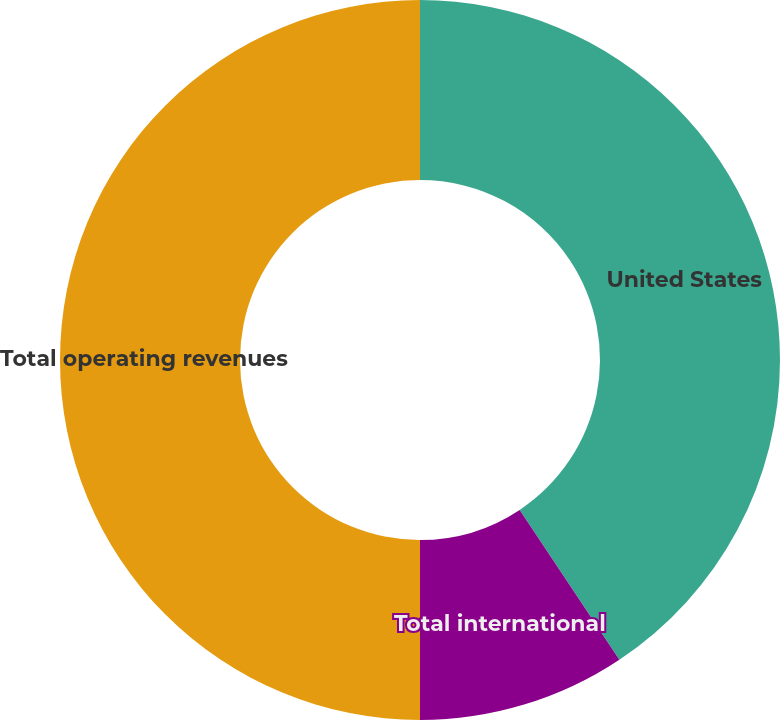Convert chart to OTSL. <chart><loc_0><loc_0><loc_500><loc_500><pie_chart><fcel>United States<fcel>Total international<fcel>Total operating revenues<nl><fcel>40.66%<fcel>9.34%<fcel>50.0%<nl></chart> 